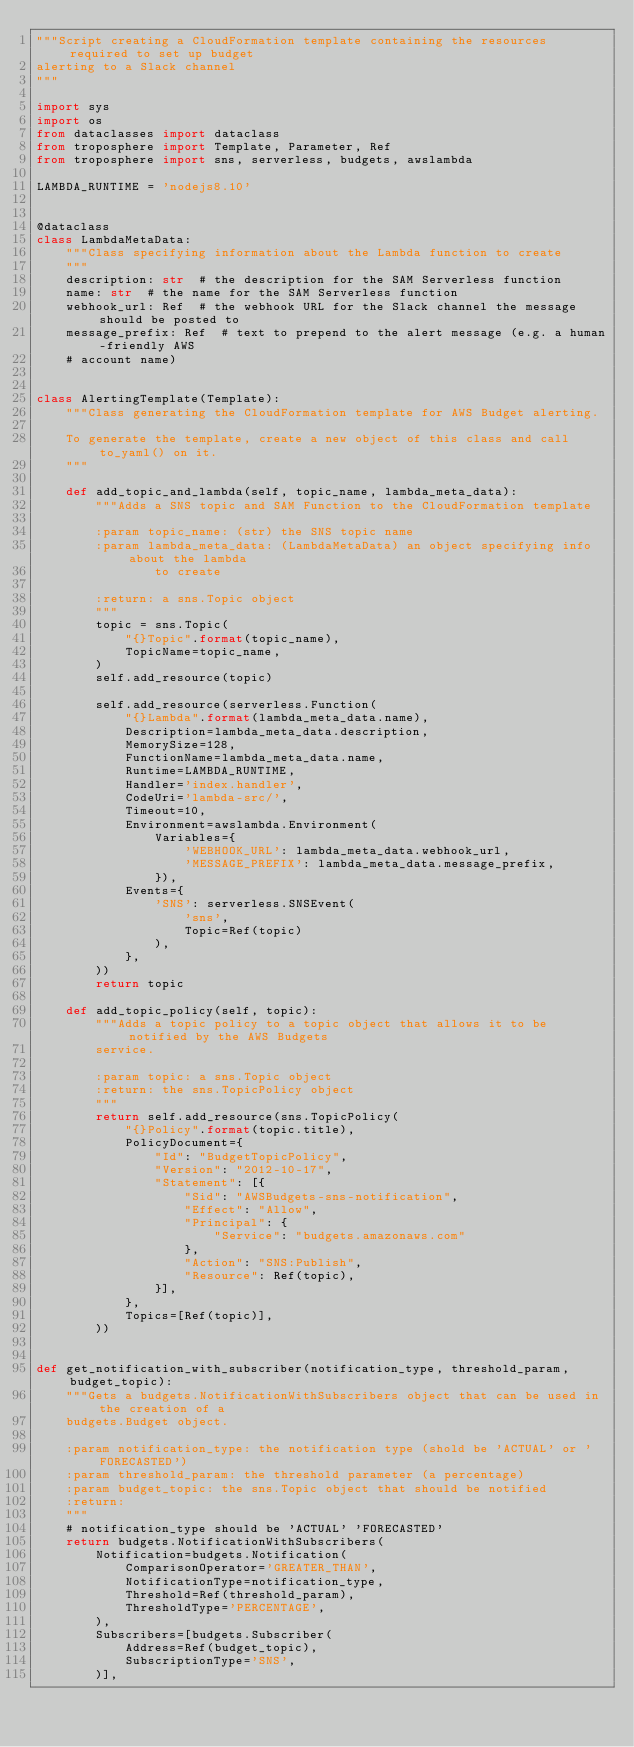<code> <loc_0><loc_0><loc_500><loc_500><_Python_>"""Script creating a CloudFormation template containing the resources required to set up budget
alerting to a Slack channel
"""

import sys
import os
from dataclasses import dataclass
from troposphere import Template, Parameter, Ref
from troposphere import sns, serverless, budgets, awslambda

LAMBDA_RUNTIME = 'nodejs8.10'


@dataclass
class LambdaMetaData:
    """Class specifying information about the Lambda function to create
    """
    description: str  # the description for the SAM Serverless function
    name: str  # the name for the SAM Serverless function
    webhook_url: Ref  # the webhook URL for the Slack channel the message should be posted to
    message_prefix: Ref  # text to prepend to the alert message (e.g. a human-friendly AWS
    # account name)


class AlertingTemplate(Template):
    """Class generating the CloudFormation template for AWS Budget alerting.

    To generate the template, create a new object of this class and call to_yaml() on it.
    """

    def add_topic_and_lambda(self, topic_name, lambda_meta_data):
        """Adds a SNS topic and SAM Function to the CloudFormation template

        :param topic_name: (str) the SNS topic name
        :param lambda_meta_data: (LambdaMetaData) an object specifying info about the lambda
                to create

        :return: a sns.Topic object
        """
        topic = sns.Topic(
            "{}Topic".format(topic_name),
            TopicName=topic_name,
        )
        self.add_resource(topic)

        self.add_resource(serverless.Function(
            "{}Lambda".format(lambda_meta_data.name),
            Description=lambda_meta_data.description,
            MemorySize=128,
            FunctionName=lambda_meta_data.name,
            Runtime=LAMBDA_RUNTIME,
            Handler='index.handler',
            CodeUri='lambda-src/',
            Timeout=10,
            Environment=awslambda.Environment(
                Variables={
                    'WEBHOOK_URL': lambda_meta_data.webhook_url,
                    'MESSAGE_PREFIX': lambda_meta_data.message_prefix,
                }),
            Events={
                'SNS': serverless.SNSEvent(
                    'sns',
                    Topic=Ref(topic)
                ),
            },
        ))
        return topic

    def add_topic_policy(self, topic):
        """Adds a topic policy to a topic object that allows it to be notified by the AWS Budgets
        service.

        :param topic: a sns.Topic object
        :return: the sns.TopicPolicy object
        """
        return self.add_resource(sns.TopicPolicy(
            "{}Policy".format(topic.title),
            PolicyDocument={
                "Id": "BudgetTopicPolicy",
                "Version": "2012-10-17",
                "Statement": [{
                    "Sid": "AWSBudgets-sns-notification",
                    "Effect": "Allow",
                    "Principal": {
                        "Service": "budgets.amazonaws.com"
                    },
                    "Action": "SNS:Publish",
                    "Resource": Ref(topic),
                }],
            },
            Topics=[Ref(topic)],
        ))


def get_notification_with_subscriber(notification_type, threshold_param, budget_topic):
    """Gets a budgets.NotificationWithSubscribers object that can be used in the creation of a
    budgets.Budget object.

    :param notification_type: the notification type (shold be 'ACTUAL' or 'FORECASTED')
    :param threshold_param: the threshold parameter (a percentage)
    :param budget_topic: the sns.Topic object that should be notified
    :return:
    """
    # notification_type should be 'ACTUAL' 'FORECASTED'
    return budgets.NotificationWithSubscribers(
        Notification=budgets.Notification(
            ComparisonOperator='GREATER_THAN',
            NotificationType=notification_type,
            Threshold=Ref(threshold_param),
            ThresholdType='PERCENTAGE',
        ),
        Subscribers=[budgets.Subscriber(
            Address=Ref(budget_topic),
            SubscriptionType='SNS',
        )],</code> 